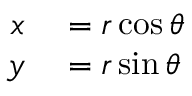Convert formula to latex. <formula><loc_0><loc_0><loc_500><loc_500>\begin{array} { r l } { x } & = r \cos \theta } \\ { y } & = r \sin \theta } \end{array}</formula> 